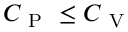Convert formula to latex. <formula><loc_0><loc_0><loc_500><loc_500>C _ { P } \leq C _ { V }</formula> 